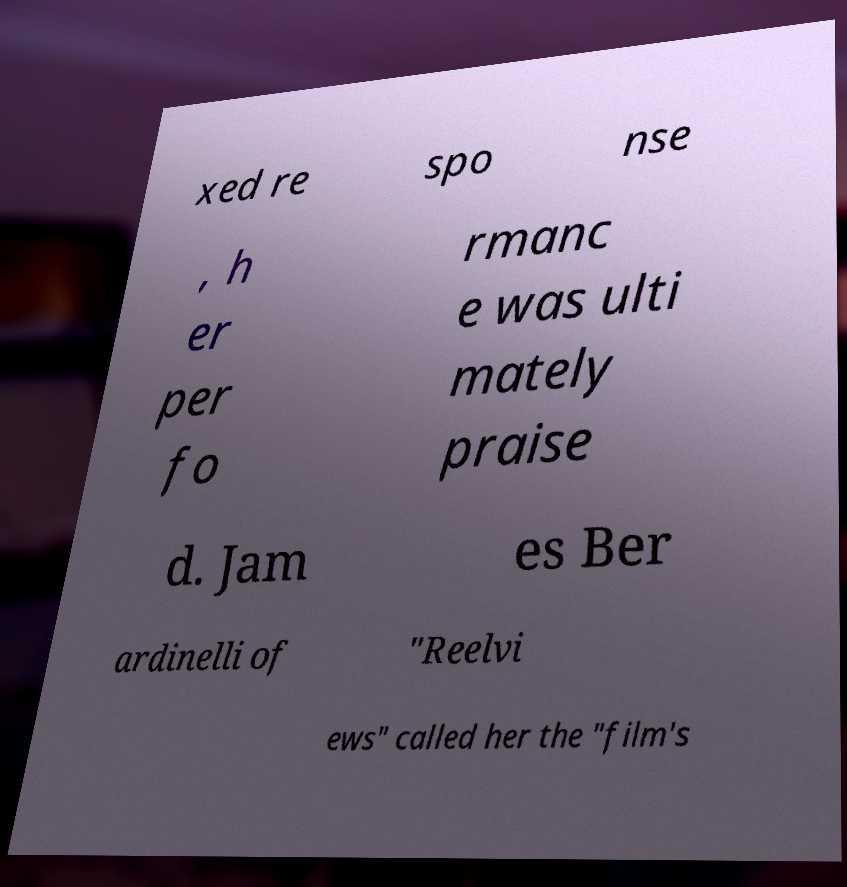Please read and relay the text visible in this image. What does it say? xed re spo nse , h er per fo rmanc e was ulti mately praise d. Jam es Ber ardinelli of "Reelvi ews" called her the "film's 